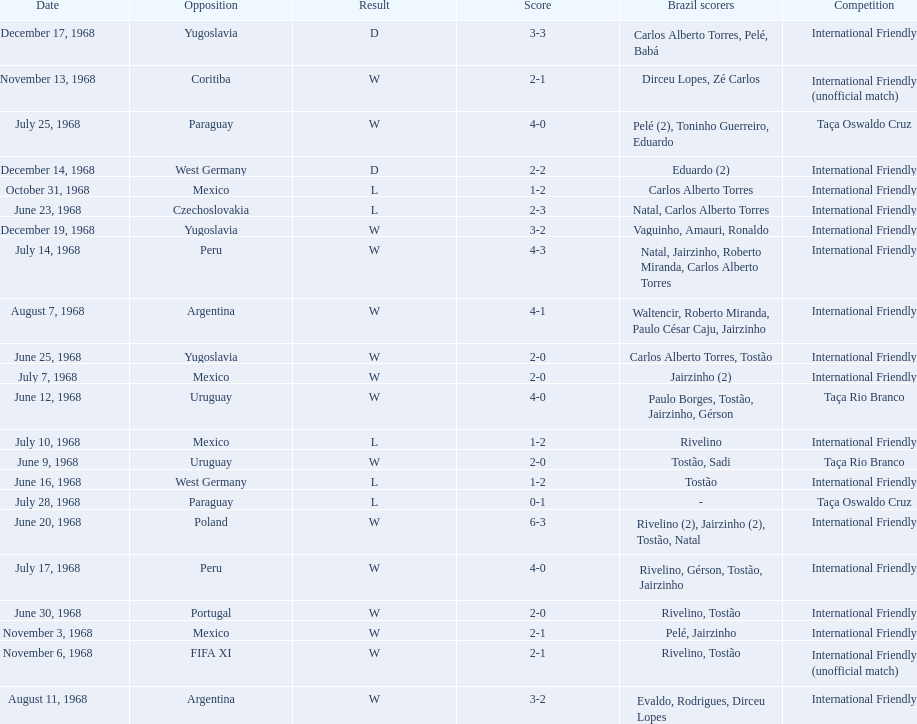How many times did brazil play against argentina in the international friendly competition? 2. 